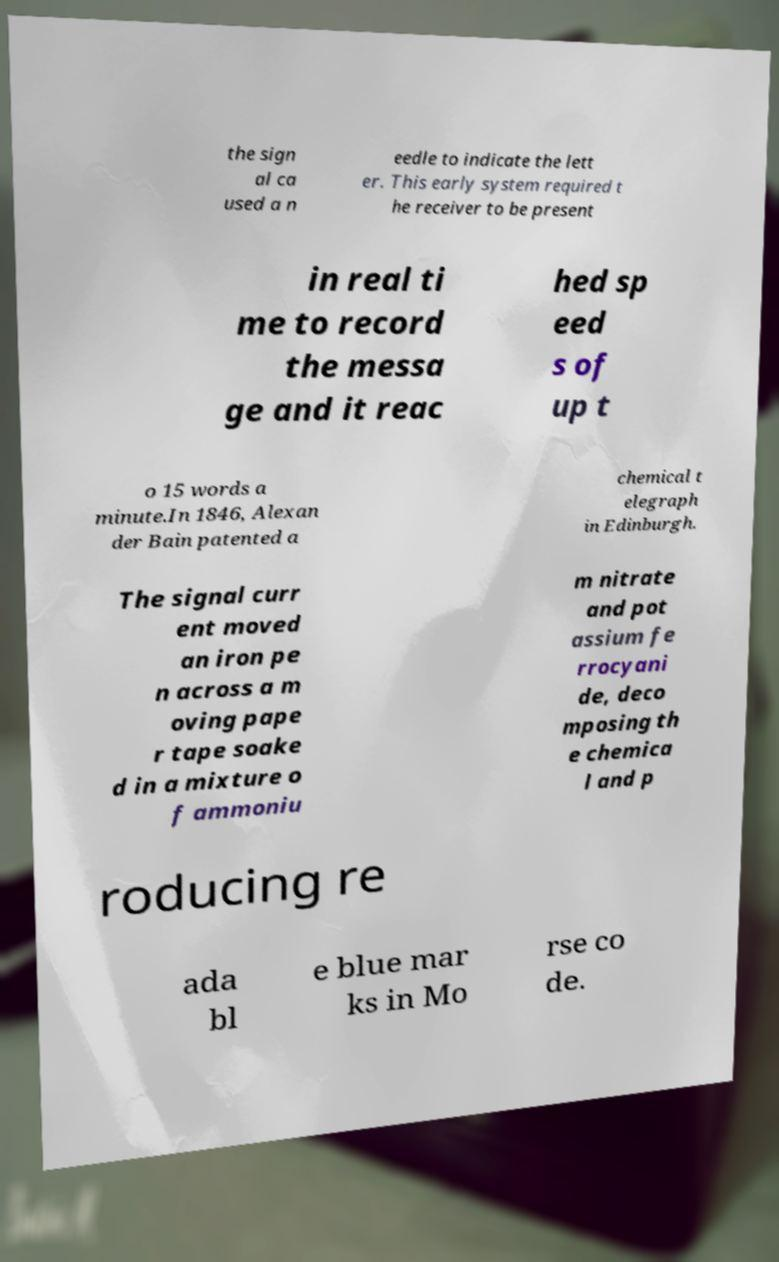What messages or text are displayed in this image? I need them in a readable, typed format. the sign al ca used a n eedle to indicate the lett er. This early system required t he receiver to be present in real ti me to record the messa ge and it reac hed sp eed s of up t o 15 words a minute.In 1846, Alexan der Bain patented a chemical t elegraph in Edinburgh. The signal curr ent moved an iron pe n across a m oving pape r tape soake d in a mixture o f ammoniu m nitrate and pot assium fe rrocyani de, deco mposing th e chemica l and p roducing re ada bl e blue mar ks in Mo rse co de. 